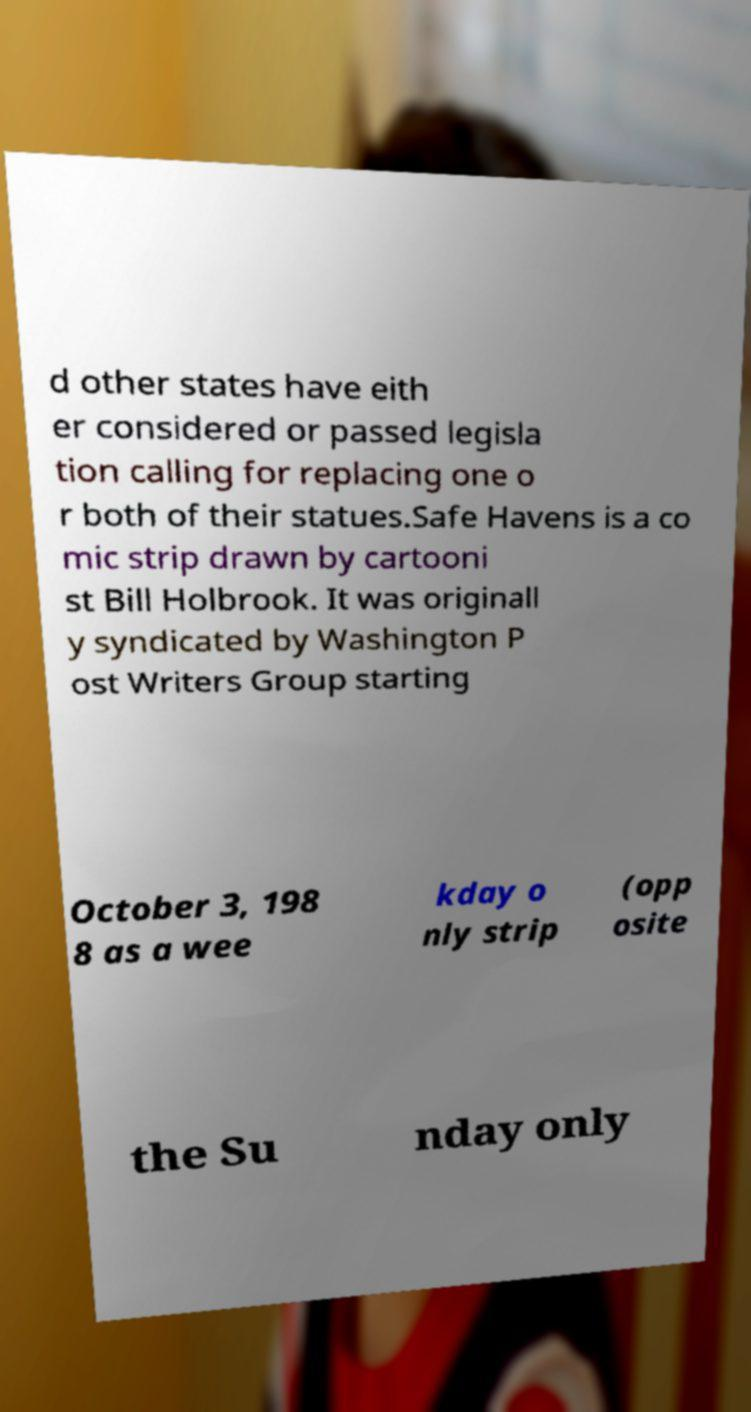Could you extract and type out the text from this image? d other states have eith er considered or passed legisla tion calling for replacing one o r both of their statues.Safe Havens is a co mic strip drawn by cartooni st Bill Holbrook. It was originall y syndicated by Washington P ost Writers Group starting October 3, 198 8 as a wee kday o nly strip (opp osite the Su nday only 